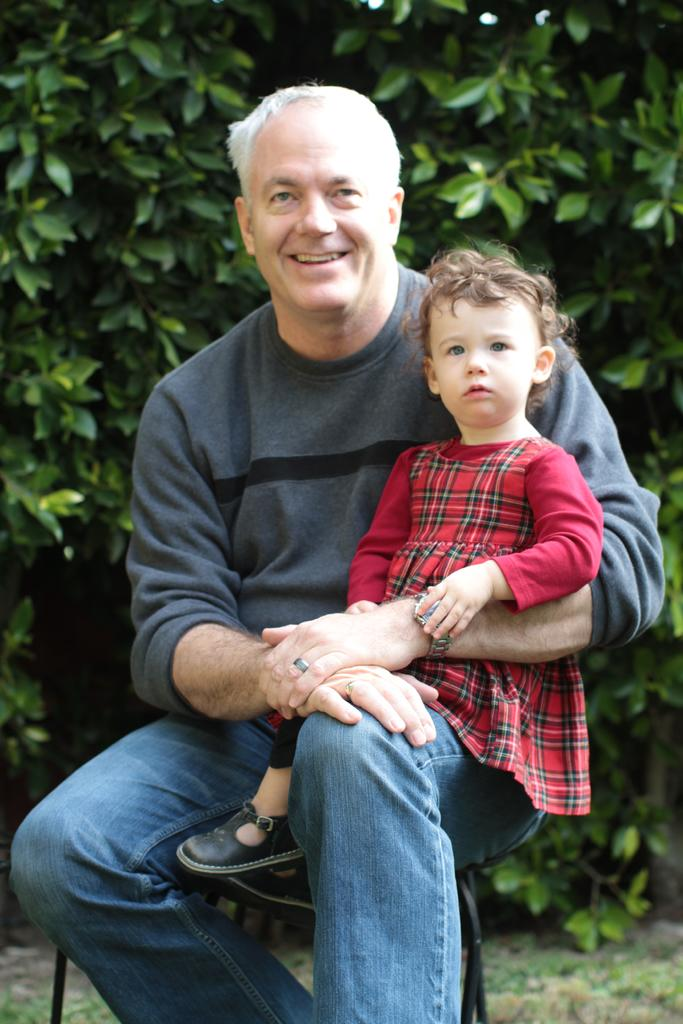What is the man in the image doing? The man is sitting on a chair in the image. What is the man holding in the image? The man is holding a baby in the image. What expression does the man have in the image? The man is smiling in the image. What can be seen in the background of the image? There are trees visible in the background of the image. What type of flesh can be seen on the man's face in the image? There is no mention of any flesh on the man's face in the image, and it is not appropriate to focus on such a detail. 